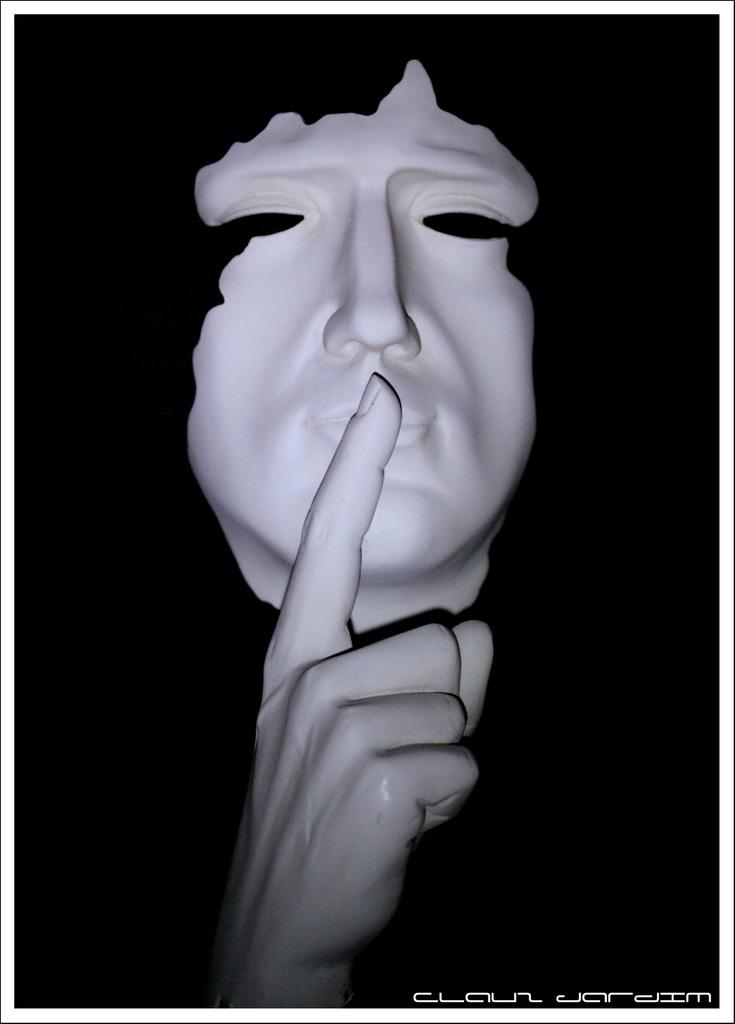What object is in the image that is typically used for protection? There is a white color mask in the image. What part of the body is visible in the image? There is a hand in the image. What is the color of the background in the image? The background of the image is black. What type of boot can be seen in the image? There is no boot present in the image. What reaction can be observed from the hand in the image? There is no reaction visible from the hand in the image; it is simply holding the mask. 